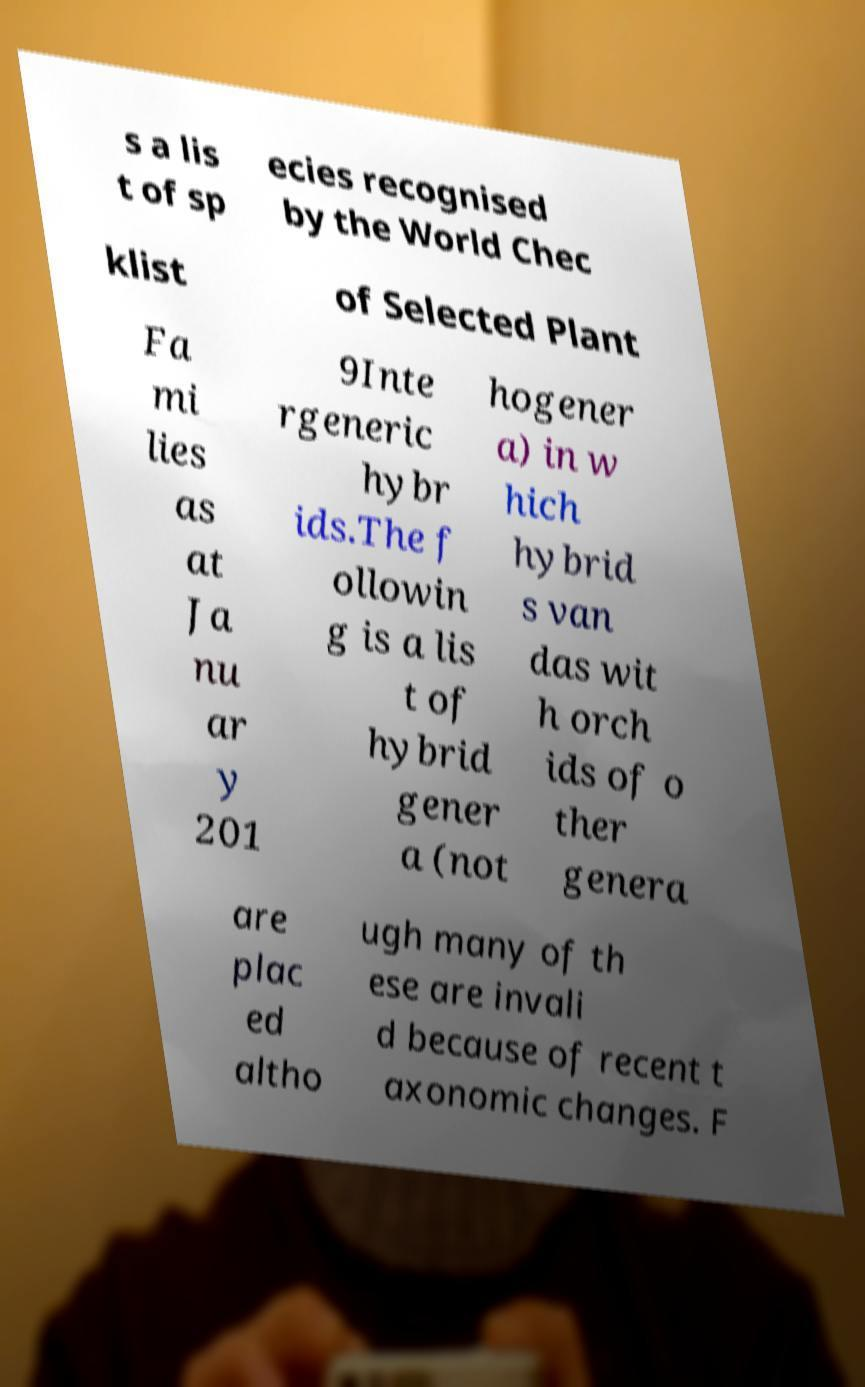What messages or text are displayed in this image? I need them in a readable, typed format. s a lis t of sp ecies recognised by the World Chec klist of Selected Plant Fa mi lies as at Ja nu ar y 201 9Inte rgeneric hybr ids.The f ollowin g is a lis t of hybrid gener a (not hogener a) in w hich hybrid s van das wit h orch ids of o ther genera are plac ed altho ugh many of th ese are invali d because of recent t axonomic changes. F 